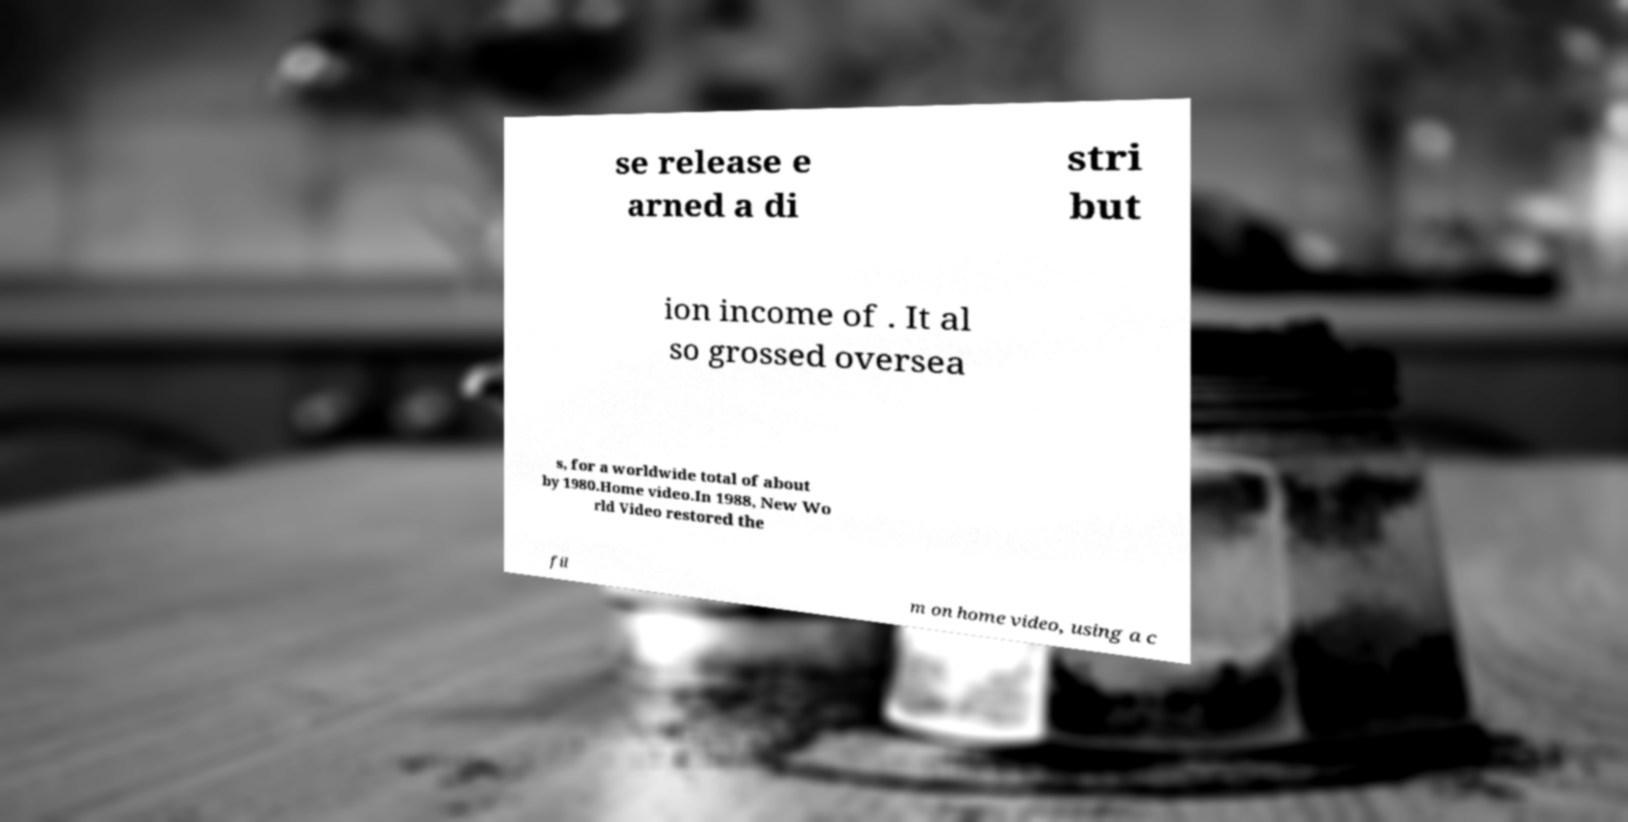Please identify and transcribe the text found in this image. se release e arned a di stri but ion income of . It al so grossed oversea s, for a worldwide total of about by 1980.Home video.In 1988, New Wo rld Video restored the fil m on home video, using a c 